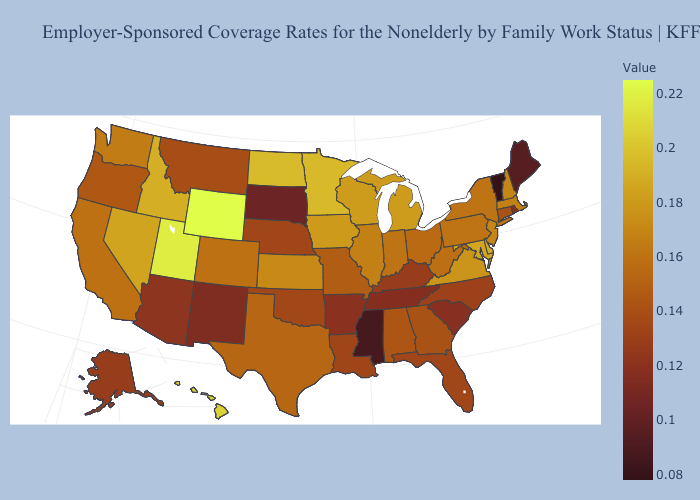Among the states that border Vermont , does New York have the lowest value?
Write a very short answer. Yes. Among the states that border Florida , which have the highest value?
Concise answer only. Alabama. Does Iowa have a higher value than Wyoming?
Give a very brief answer. No. Does New Jersey have the highest value in the Northeast?
Concise answer only. Yes. Does Maine have a lower value than Nevada?
Short answer required. Yes. Does the map have missing data?
Be succinct. No. 